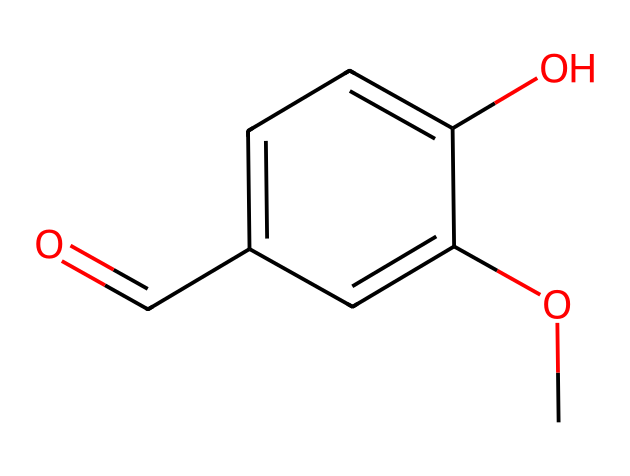What is the name of this compound? The chemical structure provided corresponds to vanillin, which is the compound commonly used for flavoring. The presence of the functional groups, particularly the aldehyde group (-C=O), confirms its identity as vanillin.
Answer: vanillin How many carbon atoms are in the structure? By analyzing the SMILES representation, we can count the number of carbon atoms denoted by 'C'. There are six carbon atoms in total within the structure.
Answer: 8 What functional groups are present in vanillin? The SMILES shows both a hydroxy group (-OH) and an aldehyde group (-C=O). These functional groups can be identified based on their typical structures visible in the representation.
Answer: hydroxy and aldehyde How many oxygen atoms are in the chemical structure? The SMILES indicates there are two oxygen atoms present in the structure, one in the hydroxy group and one in the aldehyde. Counting the occurrences of 'O' gives the total.
Answer: 2 Which part of the structure contributes to its aroma? The aldehyde group (-C=O) is responsible for the characteristic aroma of vanillin, as aldehydes are typically associated with strong, aromatic smells. This group can be identified clearly in the chemical structure.
Answer: aldehyde group Is vanillin an aldehyde or a ketone? Upon examining the functional groups, we see the presence of an aldehyde (-C=O) at the end of the carbon chain, indicating that vanillin is classified as an aldehyde.
Answer: aldehyde 